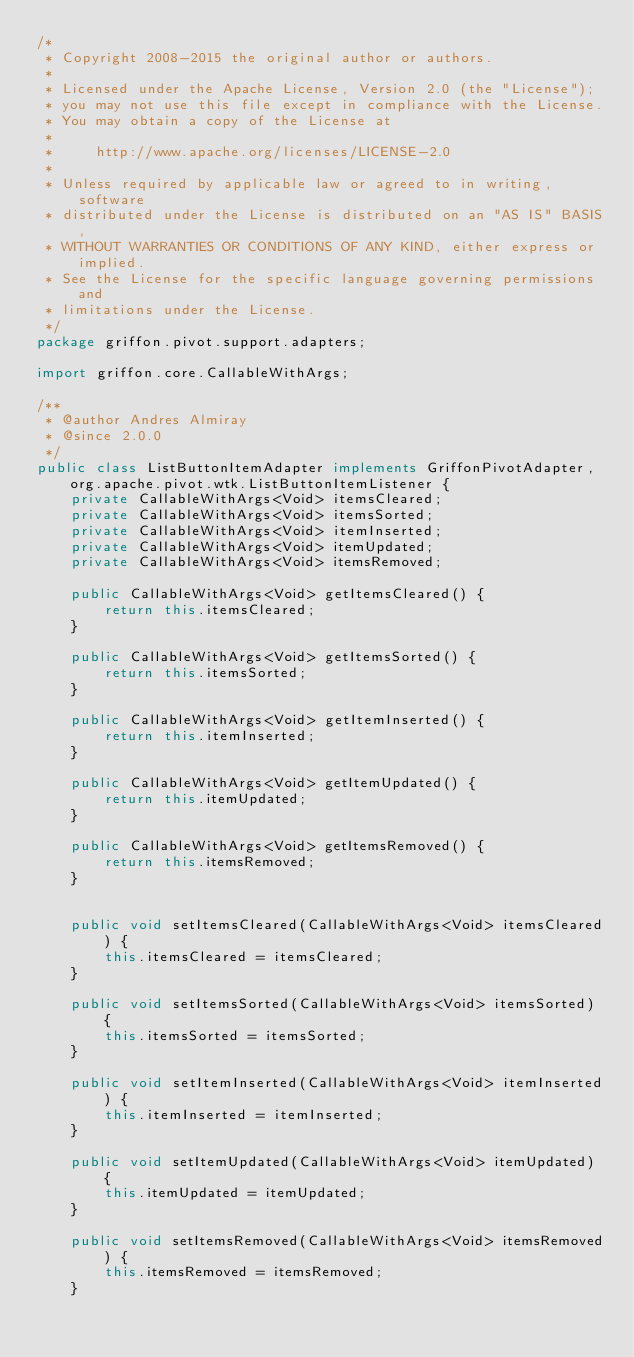Convert code to text. <code><loc_0><loc_0><loc_500><loc_500><_Java_>/*
 * Copyright 2008-2015 the original author or authors.
 *
 * Licensed under the Apache License, Version 2.0 (the "License");
 * you may not use this file except in compliance with the License.
 * You may obtain a copy of the License at
 *
 *     http://www.apache.org/licenses/LICENSE-2.0
 *
 * Unless required by applicable law or agreed to in writing, software
 * distributed under the License is distributed on an "AS IS" BASIS,
 * WITHOUT WARRANTIES OR CONDITIONS OF ANY KIND, either express or implied.
 * See the License for the specific language governing permissions and
 * limitations under the License.
 */
package griffon.pivot.support.adapters;

import griffon.core.CallableWithArgs;

/**
 * @author Andres Almiray
 * @since 2.0.0
 */
public class ListButtonItemAdapter implements GriffonPivotAdapter, org.apache.pivot.wtk.ListButtonItemListener {
    private CallableWithArgs<Void> itemsCleared;
    private CallableWithArgs<Void> itemsSorted;
    private CallableWithArgs<Void> itemInserted;
    private CallableWithArgs<Void> itemUpdated;
    private CallableWithArgs<Void> itemsRemoved;

    public CallableWithArgs<Void> getItemsCleared() {
        return this.itemsCleared;
    }

    public CallableWithArgs<Void> getItemsSorted() {
        return this.itemsSorted;
    }

    public CallableWithArgs<Void> getItemInserted() {
        return this.itemInserted;
    }

    public CallableWithArgs<Void> getItemUpdated() {
        return this.itemUpdated;
    }

    public CallableWithArgs<Void> getItemsRemoved() {
        return this.itemsRemoved;
    }


    public void setItemsCleared(CallableWithArgs<Void> itemsCleared) {
        this.itemsCleared = itemsCleared;
    }

    public void setItemsSorted(CallableWithArgs<Void> itemsSorted) {
        this.itemsSorted = itemsSorted;
    }

    public void setItemInserted(CallableWithArgs<Void> itemInserted) {
        this.itemInserted = itemInserted;
    }

    public void setItemUpdated(CallableWithArgs<Void> itemUpdated) {
        this.itemUpdated = itemUpdated;
    }

    public void setItemsRemoved(CallableWithArgs<Void> itemsRemoved) {
        this.itemsRemoved = itemsRemoved;
    }

</code> 